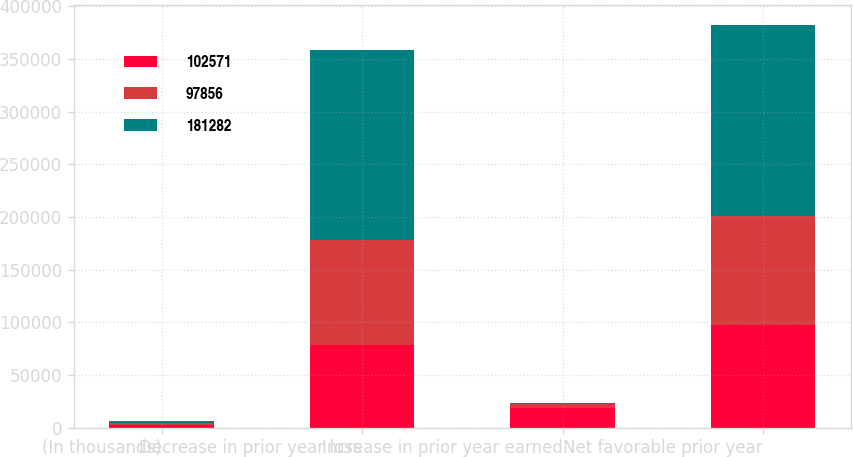<chart> <loc_0><loc_0><loc_500><loc_500><stacked_bar_chart><ecel><fcel>(In thousands)<fcel>Decrease in prior year loss<fcel>Increase in prior year earned<fcel>Net favorable prior year<nl><fcel>102571<fcel>2013<fcel>78810<fcel>19046<fcel>97856<nl><fcel>97856<fcel>2012<fcel>99343<fcel>3228<fcel>102571<nl><fcel>181282<fcel>2011<fcel>180585<fcel>697<fcel>181282<nl></chart> 